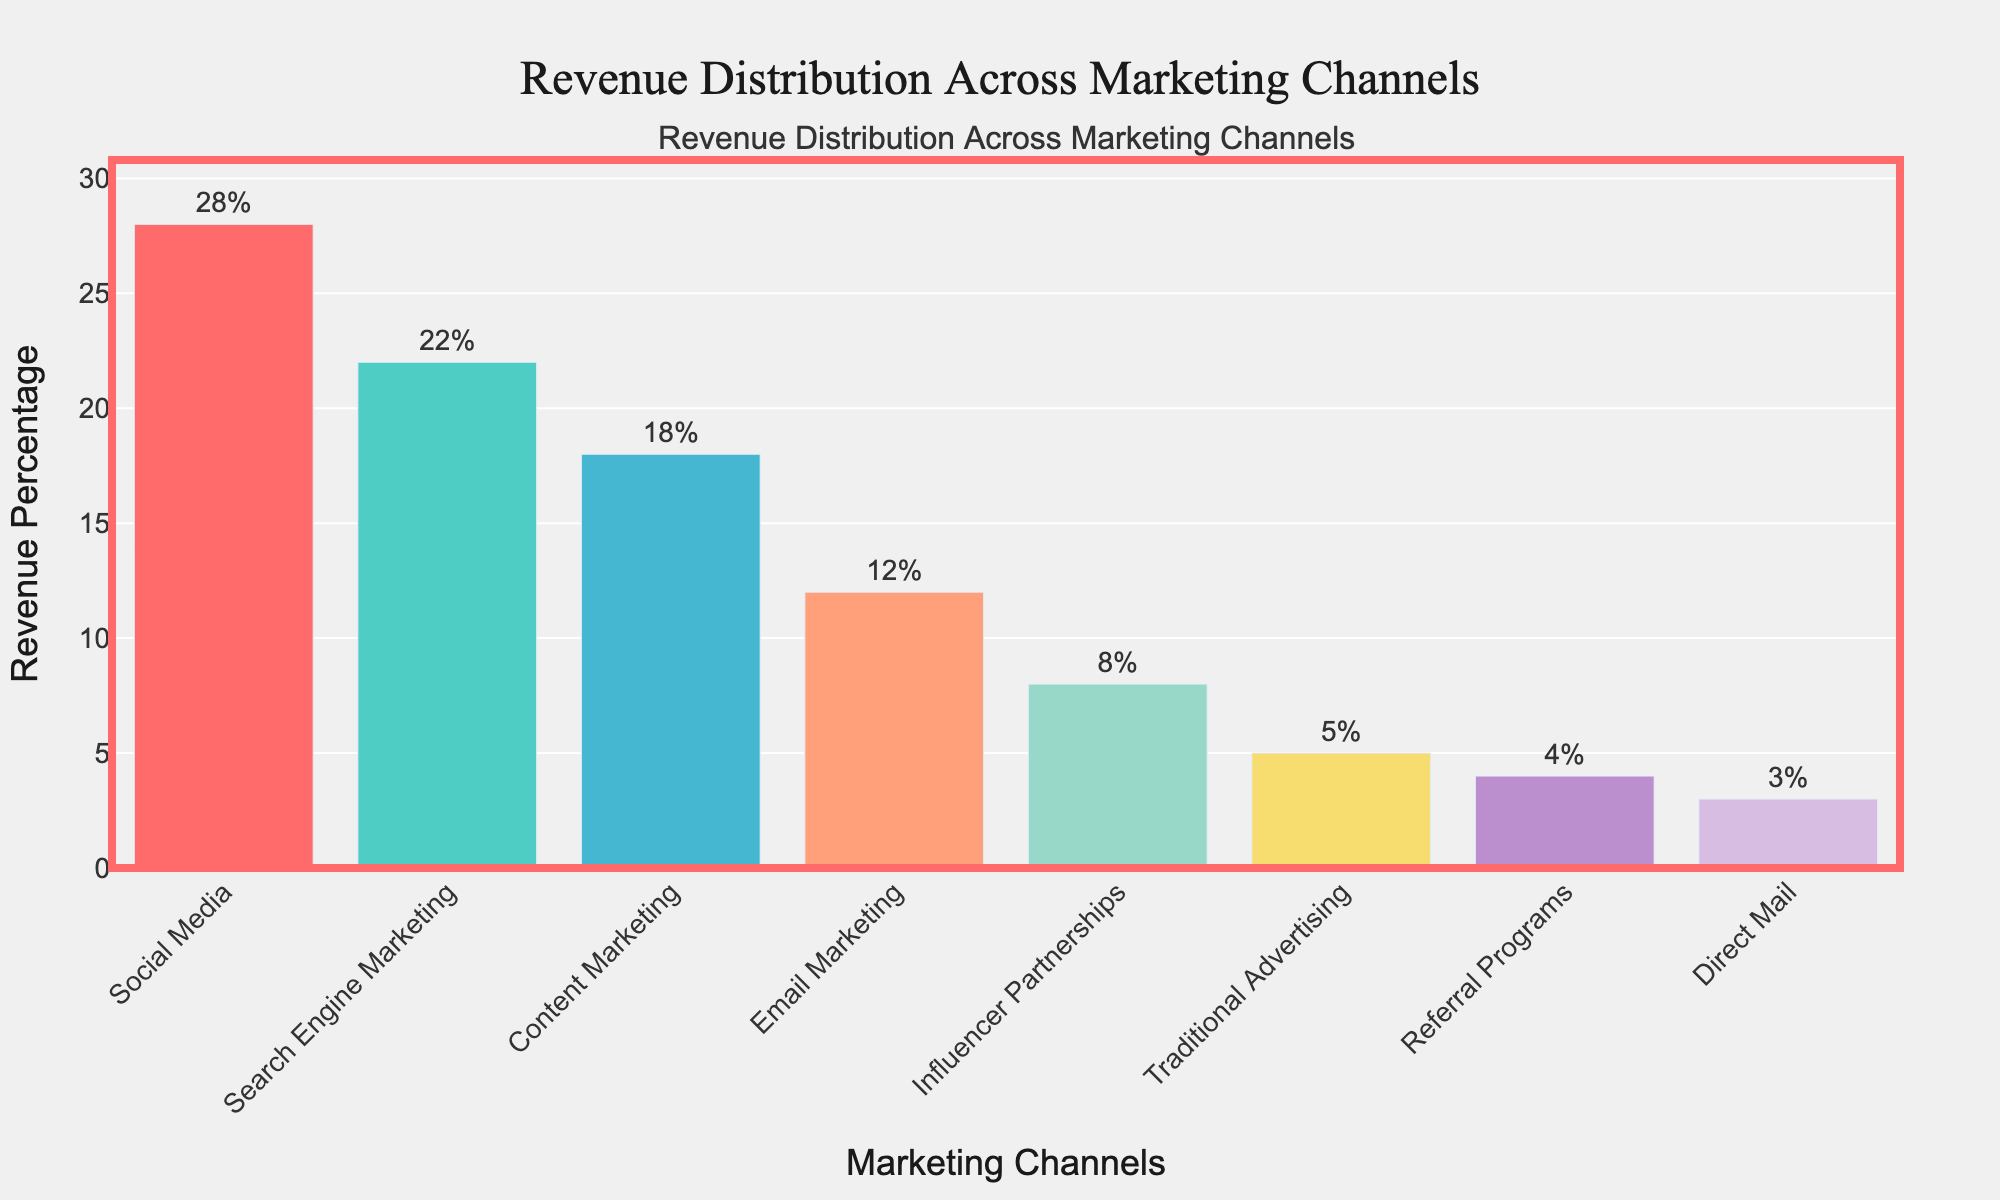What marketing channel generated the highest revenue percentage? The highest bar represents the channel generating the most revenue, which, according to the hover information, is Social Media at 28%.
Answer: Social Media Which marketing channel has the least revenue percentage and what is it? The lowest bar represents the channel with the least revenue, which is Direct Mail at 3% as shown by the hover text.
Answer: Direct Mail, 3% How much more revenue percentage does Social Media generate compared to Email Marketing? Subtract the revenue percentage of Email Marketing (12%) from Social Media (28%): 28% - 12% = 16%.
Answer: 16% What is the combined revenue percentage of the top three marketing channels? Add the revenue percentages of Social Media (28%), Search Engine Marketing (22%), and Content Marketing (18%): 28% + 22% + 18% = 68%.
Answer: 68% Which marketing channels have a revenue percentage greater than 20%? Look at the bars with revenue percentages above 20%, which are Social Media (28%) and Search Engine Marketing (22%).
Answer: Social Media and Search Engine Marketing What is the difference in revenue percentage between Influencer Partnerships and Traditional Advertising? Subtract the revenue percentage of Traditional Advertising (5%) from Influencer Partnerships (8%): 8% - 5% = 3%.
Answer: 3% How do the revenue percentages of Referral Programs and Direct Mail compare? Referral Programs have a revenue percentage of 4%, and Direct Mail has a revenue percentage of 3%. Thus, Referral Programs generate 1% more revenue.
Answer: Referral Programs generate 1% more What is the average revenue percentage among all marketing channels? Sum all revenue percentages (28 + 22 + 18 + 12 + 8 + 5 + 4 + 3 = 100) and divide by the number of channels (8): 100 / 8 = 12.5%.
Answer: 12.5% Which marketing channels have a revenue percentage less than 10%? The channels with bars shorter than the ones indicating 10% are Influencer Partnerships (8%), Traditional Advertising (5%), Referral Programs (4%), and Direct Mail (3%).
Answer: Influencer Partnerships, Traditional Advertising, Referral Programs, Direct Mail What is the combined revenue percentage of Email Marketing and Influencer Partnerships compared to Traditional Advertising and Referral Programs? Add the revenue percentages: Email Marketing (12%) + Influencer Partnerships (8%) = 20%; Traditional Advertising (5%) + Referral Programs (4%) = 9%. So, 20% versus 9%.
Answer: 20% vs. 9% 